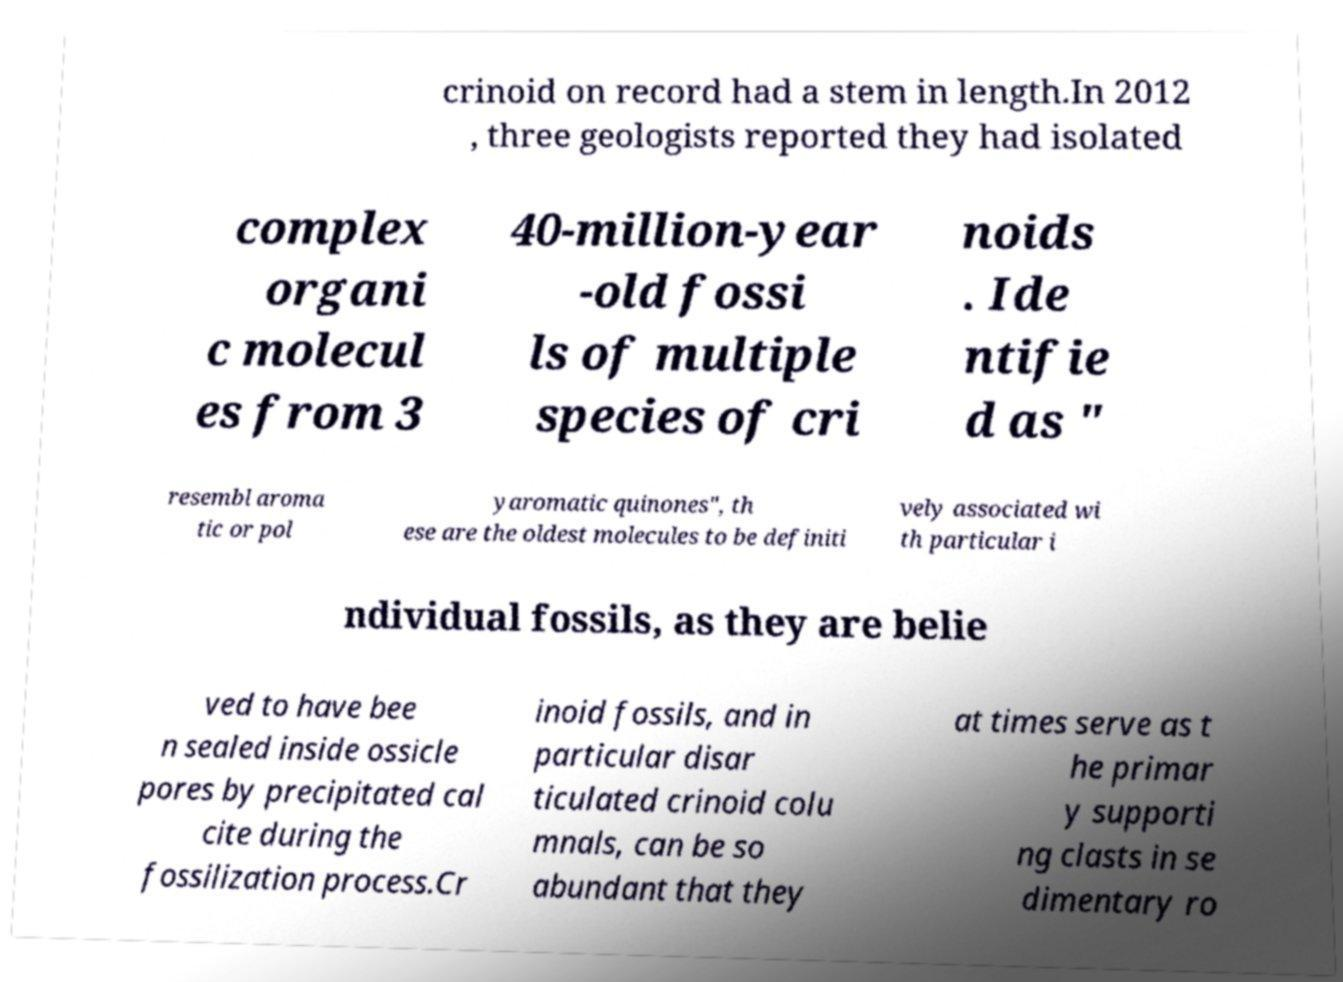Can you read and provide the text displayed in the image?This photo seems to have some interesting text. Can you extract and type it out for me? crinoid on record had a stem in length.In 2012 , three geologists reported they had isolated complex organi c molecul es from 3 40-million-year -old fossi ls of multiple species of cri noids . Ide ntifie d as " resembl aroma tic or pol yaromatic quinones", th ese are the oldest molecules to be definiti vely associated wi th particular i ndividual fossils, as they are belie ved to have bee n sealed inside ossicle pores by precipitated cal cite during the fossilization process.Cr inoid fossils, and in particular disar ticulated crinoid colu mnals, can be so abundant that they at times serve as t he primar y supporti ng clasts in se dimentary ro 